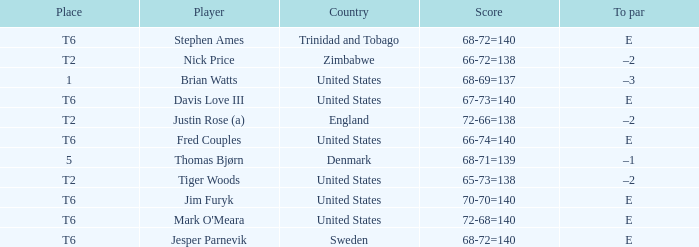What was the TO par for the player who scored 68-69=137? –3. 